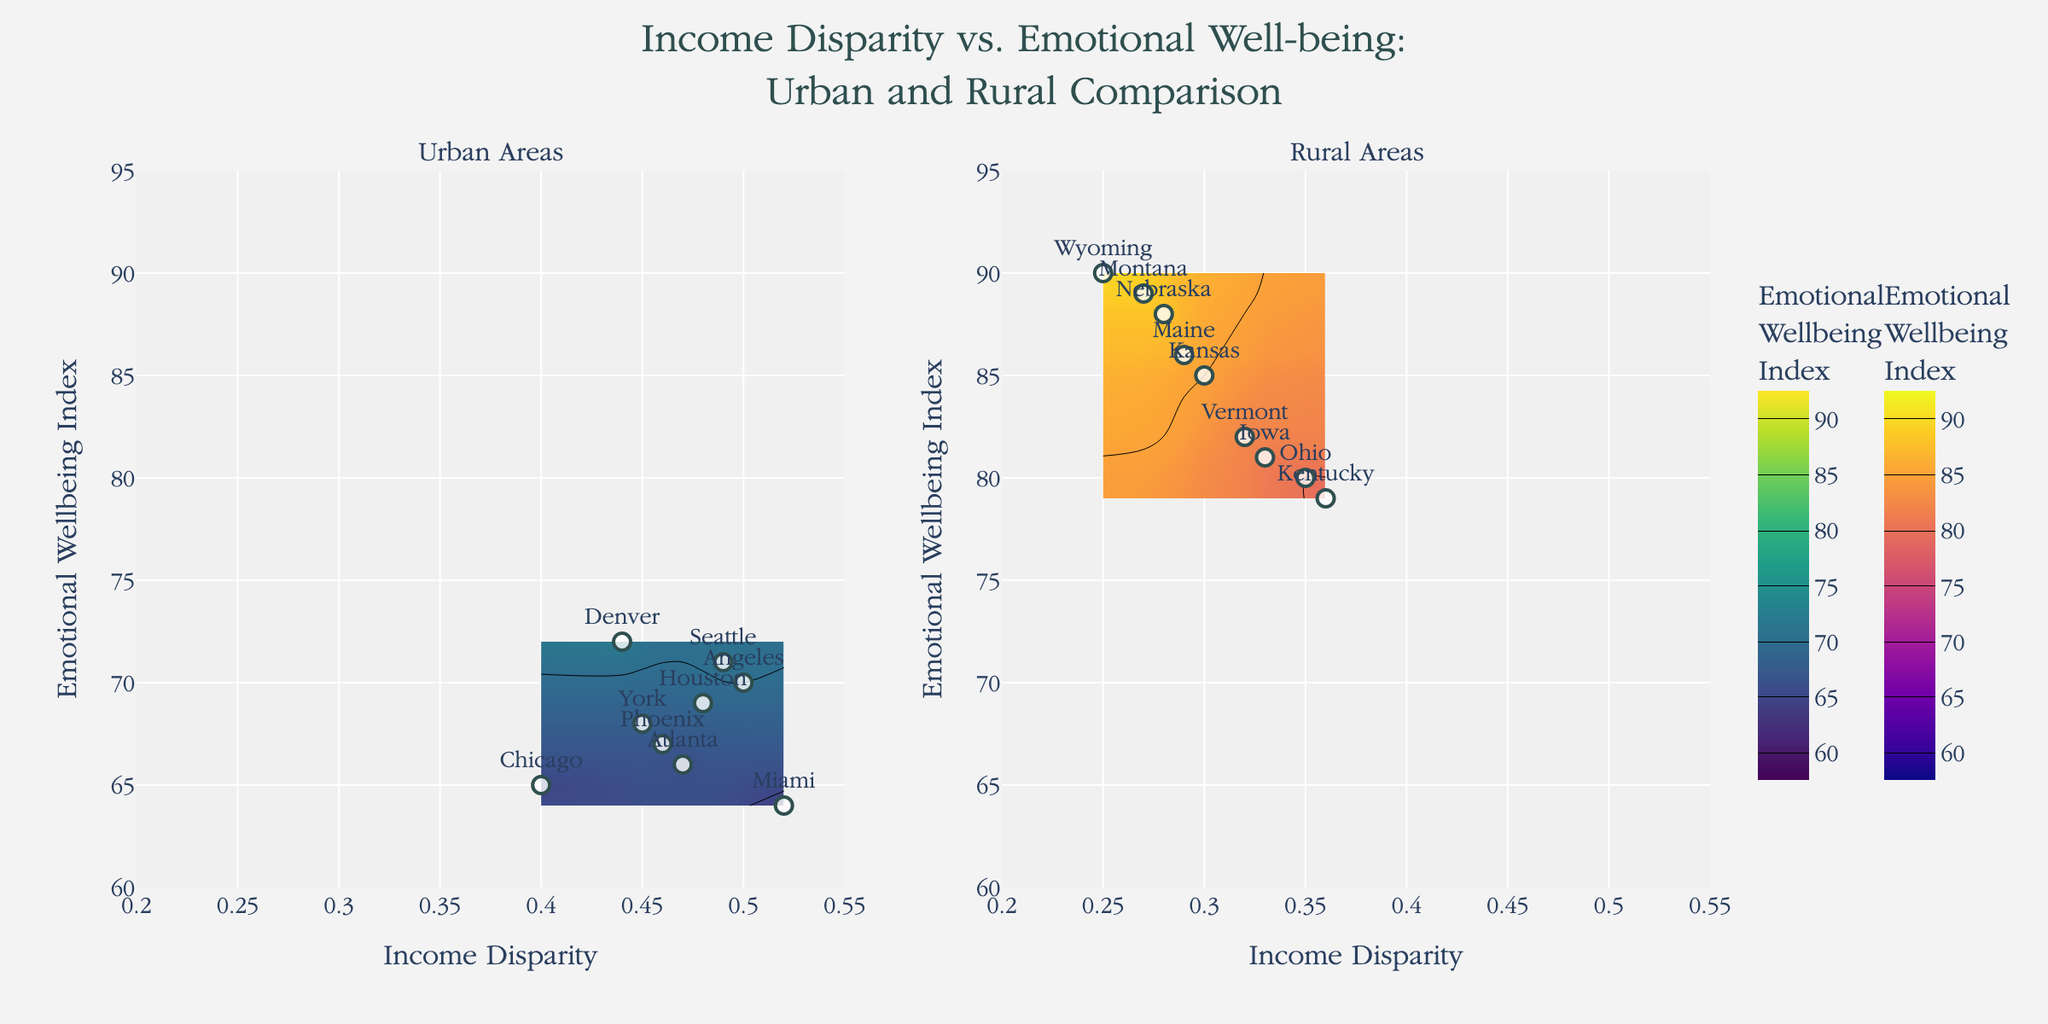What is the title of the figure? The title is displayed prominently at the top of the figure.
Answer: Income Disparity vs. Emotional Well-being: Urban and Rural Comparison How many data points are in the Urban Areas plot? Look at the scatter plot in the left subplot titled "Urban Areas" and count the markers.
Answer: 10 Which region has the highest Emotional Well-being Index in the Rural Areas? In the contour plot on the right titled "Rural Areas", find the region with the maximum y-value on the Emotional Well-being Index.
Answer: Wyoming Which region in the Urban Areas has the lowest Emotional Well-being Index, and what is its value? Check the urban plot for the lowest point on the y-axis and identify the corresponding region and its value.
Answer: Miami, 64 What is the range of the Income Disparity axis? The range of the x-axis is indicated by the axis marks.
Answer: 0.2 to 0.55 How does the correlation between Income Disparity and Emotional Well-being Index differ between Urban and Rural Areas? Observe the general trend in both subplots: whether the contours indicate a positive or negative correlation. In Urban Areas, as Income Disparity increases, Emotional Well-being doesn't show a consistent increase or decrease, while in Rural Areas, as Income Disparity increases, there is a slight decrease in Emotional Well-being.
Answer: In Urban Areas, there is no clear correlation; in Rural Areas, Emotional Well-being decreases slightly with increasing Income Disparity What contour color scheme is used for Urban Areas? Check the legend or colors in the left subplot titled "Urban Areas".
Answer: Viridis Compare the Emotional Well-being Index of Urban Los Angeles and Rural Kansas. Which is higher, and by how much? Locate the points for Urban Los Angeles and Rural Kansas in the subplots. Compare their y-values. Emotional Well-being Index for Los Angeles is 70, and for Kansas is 85; the difference is 85 - 70 = 15.
Answer: Kansas is higher by 15 Which region appears to achieve balance with low income disparity and high well-being in Rural Areas? Look at the Rural Areas subplot and identify a region with low Income Disparity (x-value) and high Emotional Well-being Index (y-value).
Answer: Nebraska 